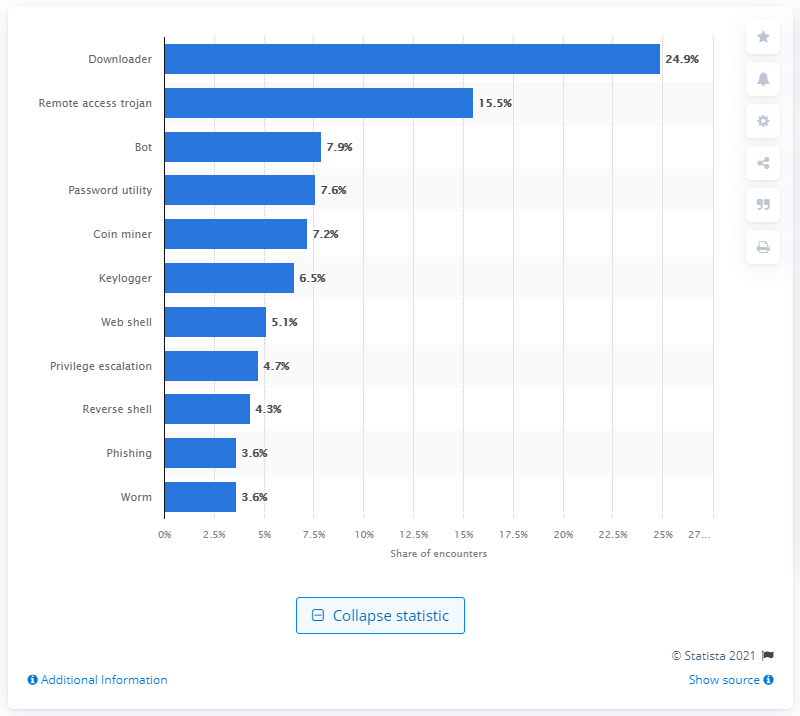Draw attention to some important aspects in this diagram. During the survey period, downloaders were found to have detected approximately 24.9% of all malware attacks. 